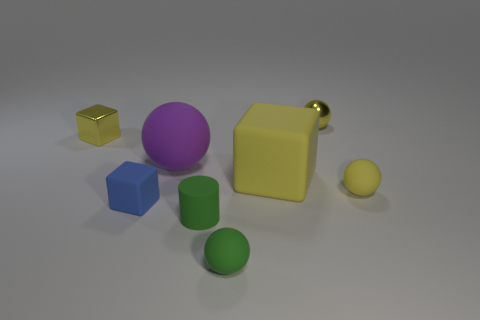Subtract all yellow cubes. How many cubes are left? 1 Subtract all yellow blocks. How many blocks are left? 1 Subtract 2 blocks. How many blocks are left? 1 Subtract all cyan cubes. Subtract all green cylinders. How many cubes are left? 3 Add 1 purple things. How many objects exist? 9 Subtract 0 yellow cylinders. How many objects are left? 8 Subtract all cylinders. How many objects are left? 7 Subtract all cyan balls. How many purple blocks are left? 0 Subtract all gray rubber blocks. Subtract all big cubes. How many objects are left? 7 Add 1 blue objects. How many blue objects are left? 2 